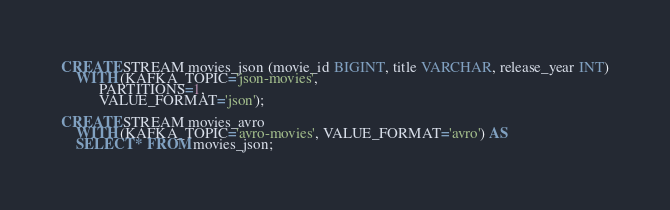Convert code to text. <code><loc_0><loc_0><loc_500><loc_500><_SQL_>CREATE STREAM movies_json (movie_id BIGINT, title VARCHAR, release_year INT)
    WITH (KAFKA_TOPIC='json-movies',
          PARTITIONS=1,
          VALUE_FORMAT='json');

CREATE STREAM movies_avro
    WITH (KAFKA_TOPIC='avro-movies', VALUE_FORMAT='avro') AS
    SELECT * FROM movies_json;
</code> 